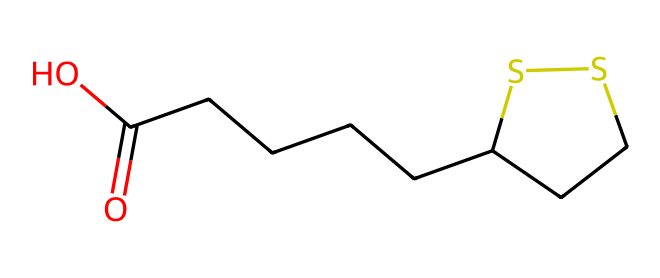What is the molecular formula of lipoic acid? To find the molecular formula from the SMILES representation, we can identify and count each type of atom present. The SMILES code shows carbon (C), oxygen (O), and sulfur (S) atoms. By counting the number of each atom, we determine that the molecular formula is C8H14O2S2.
Answer: C8H14O2S2 How many sulfur atoms are in the lipoic acid structure? By carefully examining the SMILES representation, we can locate the sulfur (S) symbols. There are two 'S' symbols in the structure, indicating there are two sulfur atoms in lipoic acid.
Answer: 2 What type of compound is lipoic acid? Lipoic acid contains sulfur atoms in its structure, classifying it as an organosulfur compound. Since it contains a carboxylic acid group (indicated by the presence of -COOH), it is specifically termed as such.
Answer: organosulfur How many rings are present in the lipoic acid structure? The SMILES structure includes a part that suggests cyclic structures, specifically denoted by 'CCSS1'. Evaluating this portion indicates there is one ring present in lipoic acid.
Answer: 1 What functional groups are present in lipoic acid? In the SMILES notation, the presence of "O=C(O)" indicates a carboxylic acid functional group (-COOH), while the sulfur atoms suggest additional functional characteristics associated with organosulfur compounds.
Answer: carboxylic acid What is the total number of carbon atoms in lipoic acid? By analyzing the SMILES structure, we can count all carbon atoms denoted by 'C'. Counting through the entire SMILES string shows there are a total of eight carbon atoms in lipoic acid.
Answer: 8 